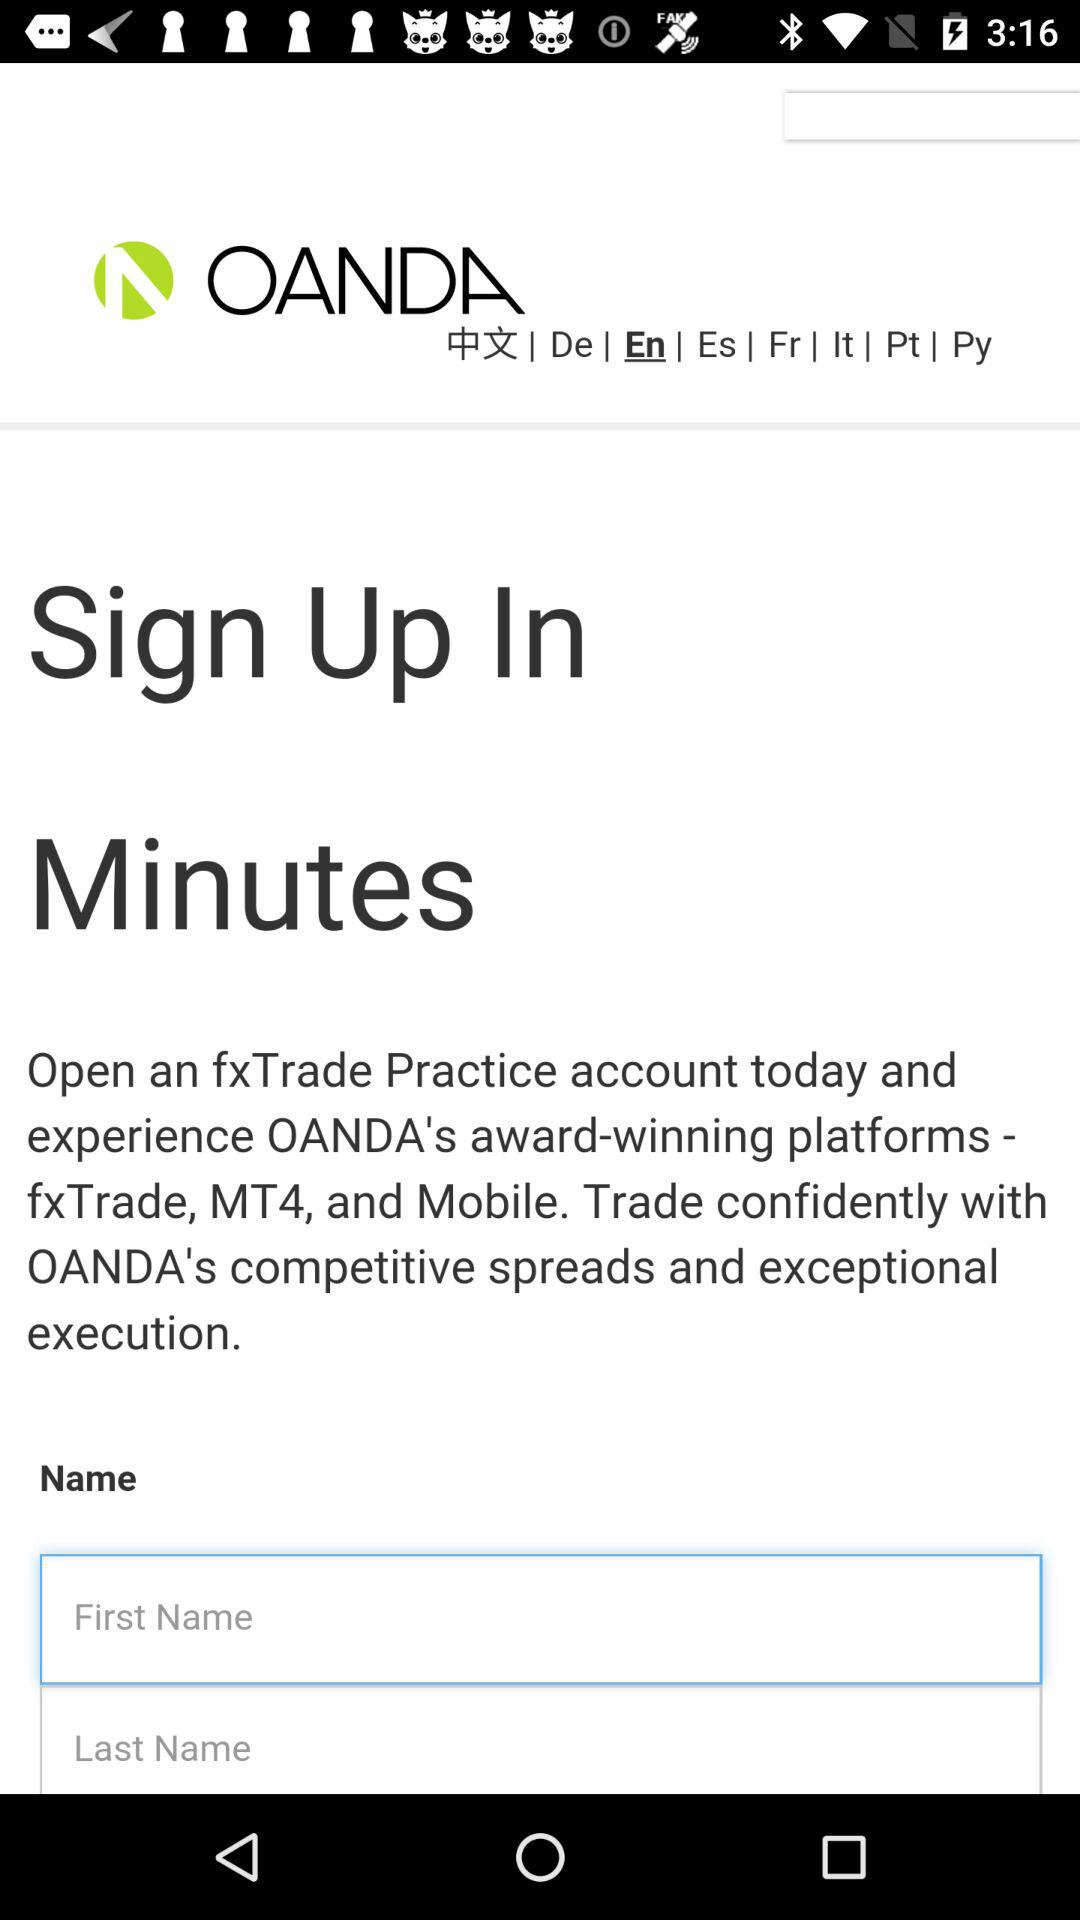How many text inputs are there for the user to enter their name?
Answer the question using a single word or phrase. 2 